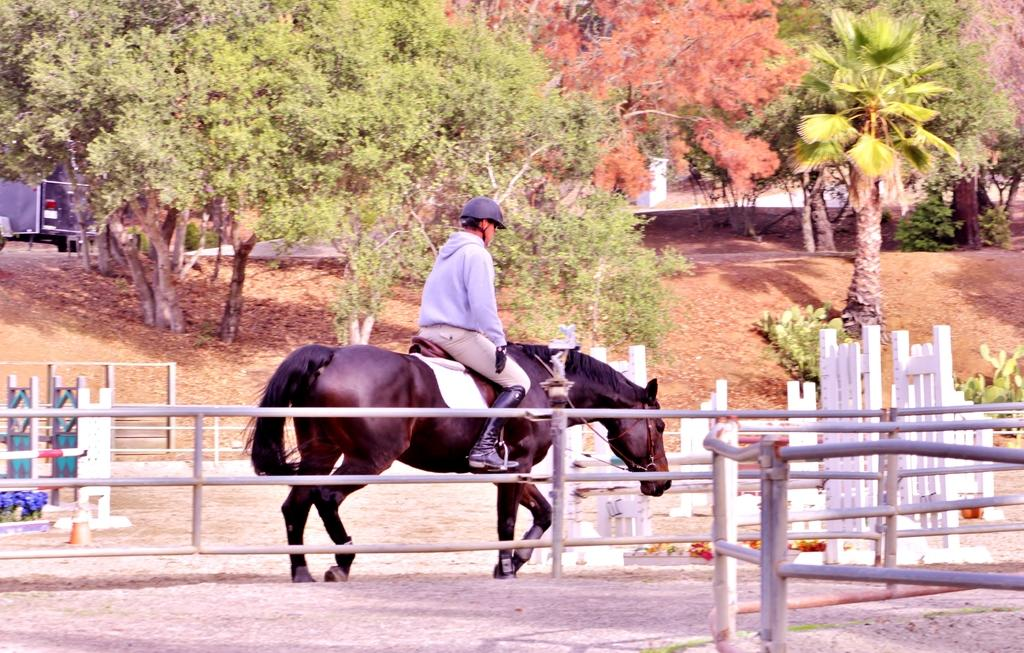What is the person in the image doing? The person is sitting on a horse in the image. What is in front of the horse? There is an iron fence in front of the horse. What is on the path behind the horse? There is a vehicle on the path behind the horse. What can be seen in the distance in the image? Trees are visible in the background of the image. What type of sign can be seen on the horse's tail in the image? There is no sign present on the horse's tail in the image. What kind of ray is swimming near the horse in the image? There is no ray present in the image; it is a land-based scene with a horse, person, and vehicle. 